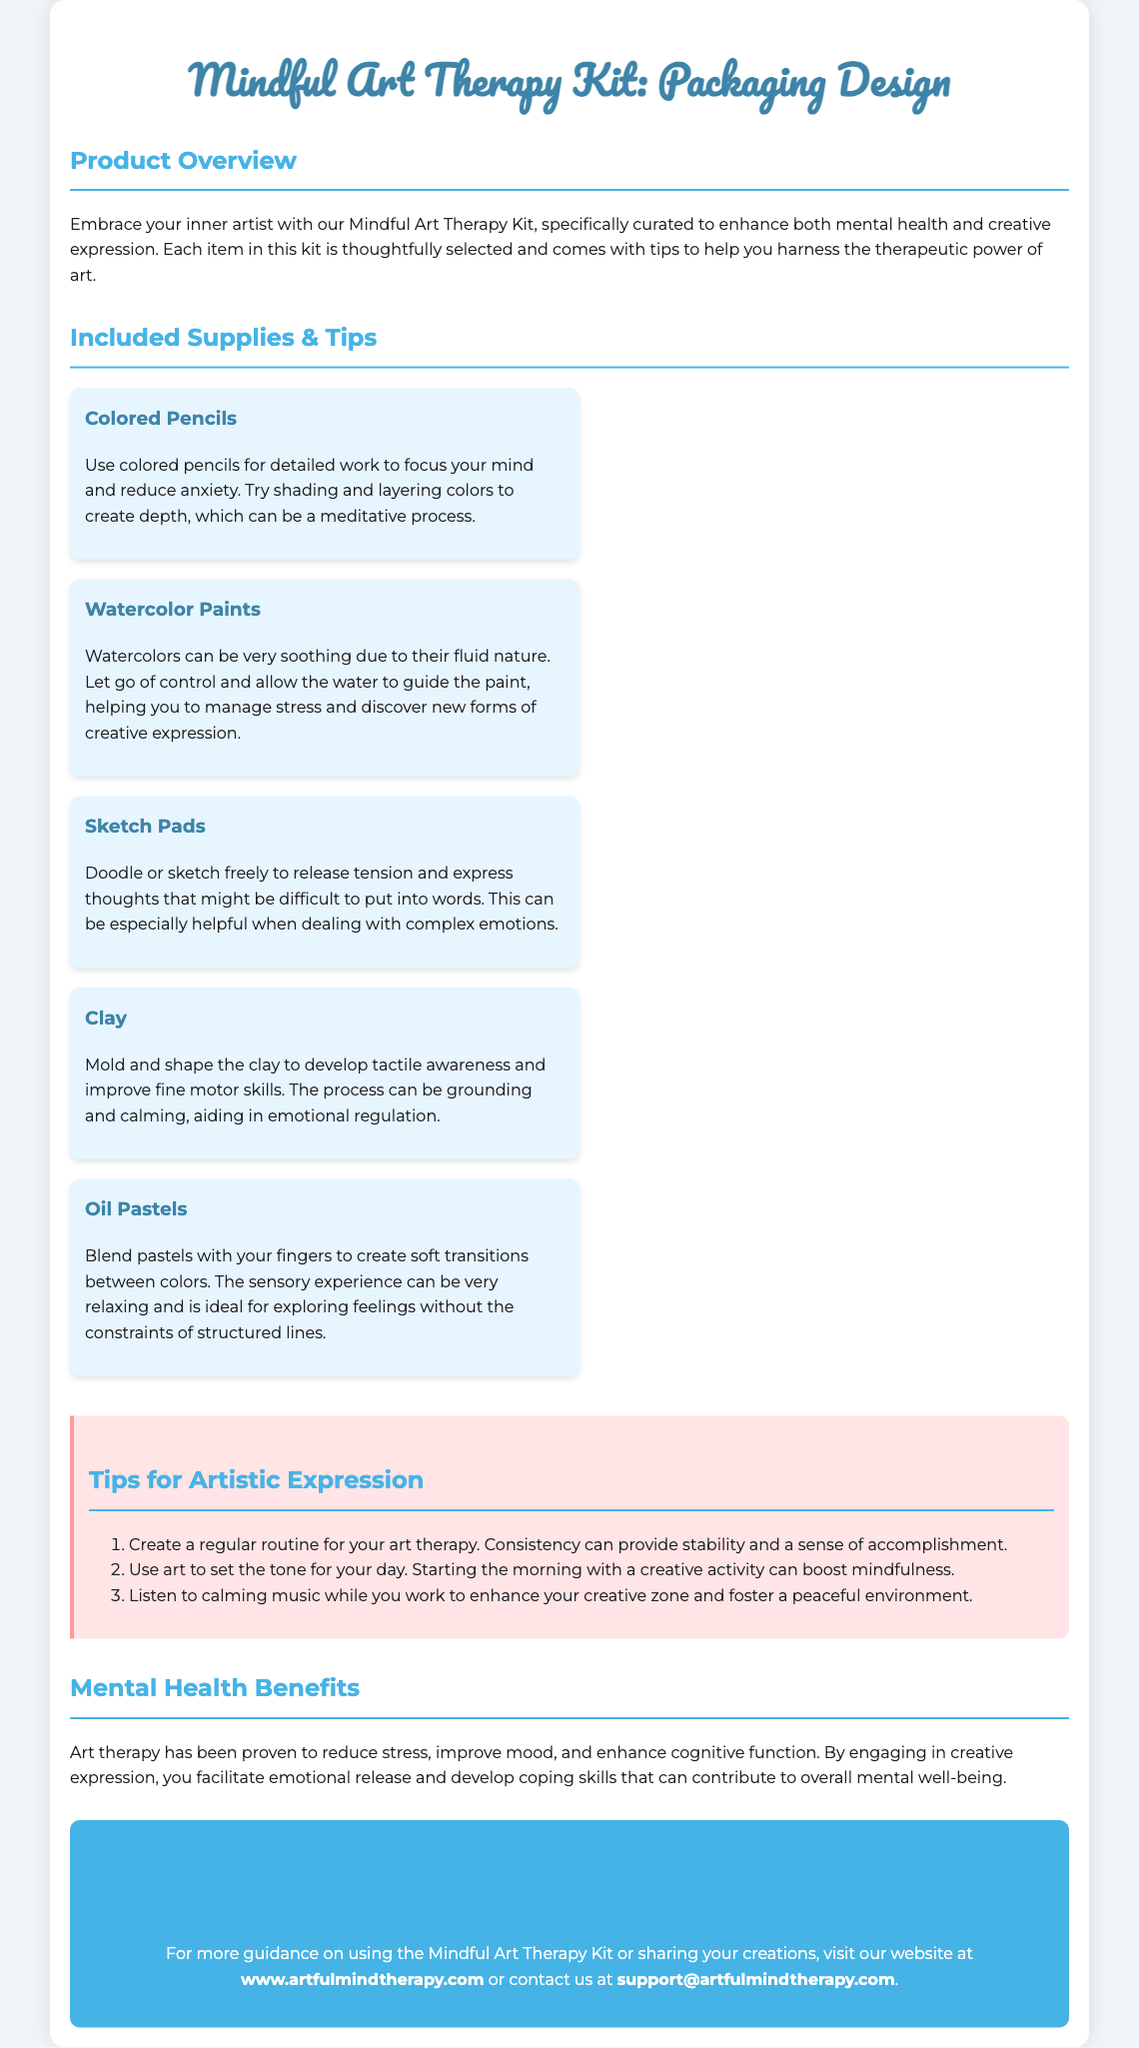What is the name of the product? The name of the product is found in the header section of the document.
Answer: Mindful Art Therapy Kit How many types of supplies are included? The supply section lists five different types of supplies, which can be counted.
Answer: Five Which supply helps to manage stress through fluidity? The supply is described in the document as aiding in stress management due to its nature.
Answer: Watercolor Paints What is a recommended routine for art therapy? The document suggests establishing a routine for art therapy to provide stability.
Answer: Create a regular routine What is one benefit of art therapy mentioned? The document lists benefits of art therapy and one specific benefit can be identified.
Answer: Reduce stress What color is used for the heading of the supplies? The color of the heading for each supply item is stated in the style section of the document.
Answer: #3d84a8 What activity is recommended to enhance the creative zone? The document provides tips that include activities to enhance the creative space.
Answer: Listen to calming music What is the website for more guidance? The contact information section provides the website address for further assistance.
Answer: www.artfulmindtherapy.com 